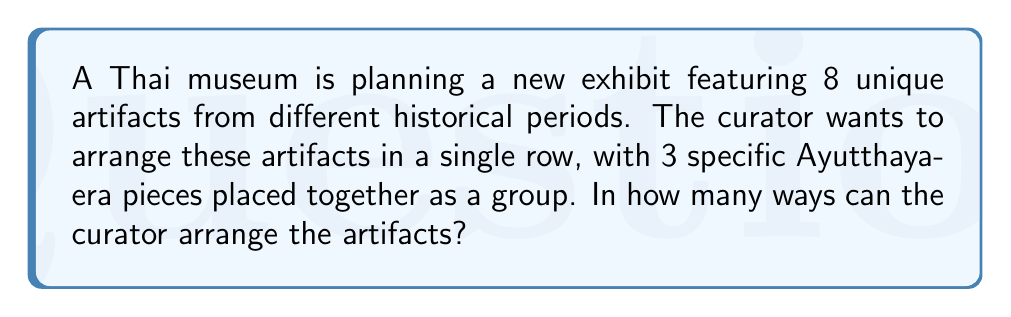Give your solution to this math problem. Let's approach this step-by-step:

1) First, consider the 3 Ayutthaya-era pieces as one unit. This means we now have 6 elements to arrange:
   - The Ayutthaya-era unit (containing 3 pieces)
   - 5 other individual artifacts

2) These 6 elements can be arranged in $6!$ ways.

3) However, within the Ayutthaya-era unit, the 3 pieces can also be arranged in different ways. This gives us an additional $3!$ permutations.

4) By the multiplication principle, the total number of ways to arrange the artifacts is:

   $$ 6! \times 3! $$

5) Let's calculate this:
   $$ 6! \times 3! = (6 \times 5 \times 4 \times 3 \times 2 \times 1) \times (3 \times 2 \times 1) $$
   $$ = 720 \times 6 = 4,320 $$

Therefore, the curator can arrange the artifacts in 4,320 different ways.
Answer: 4,320 